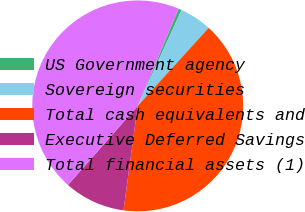Convert chart. <chart><loc_0><loc_0><loc_500><loc_500><pie_chart><fcel>US Government agency<fcel>Sovereign securities<fcel>Total cash equivalents and<fcel>Executive Deferred Savings<fcel>Total financial assets (1)<nl><fcel>0.49%<fcel>4.92%<fcel>40.4%<fcel>9.35%<fcel>44.83%<nl></chart> 